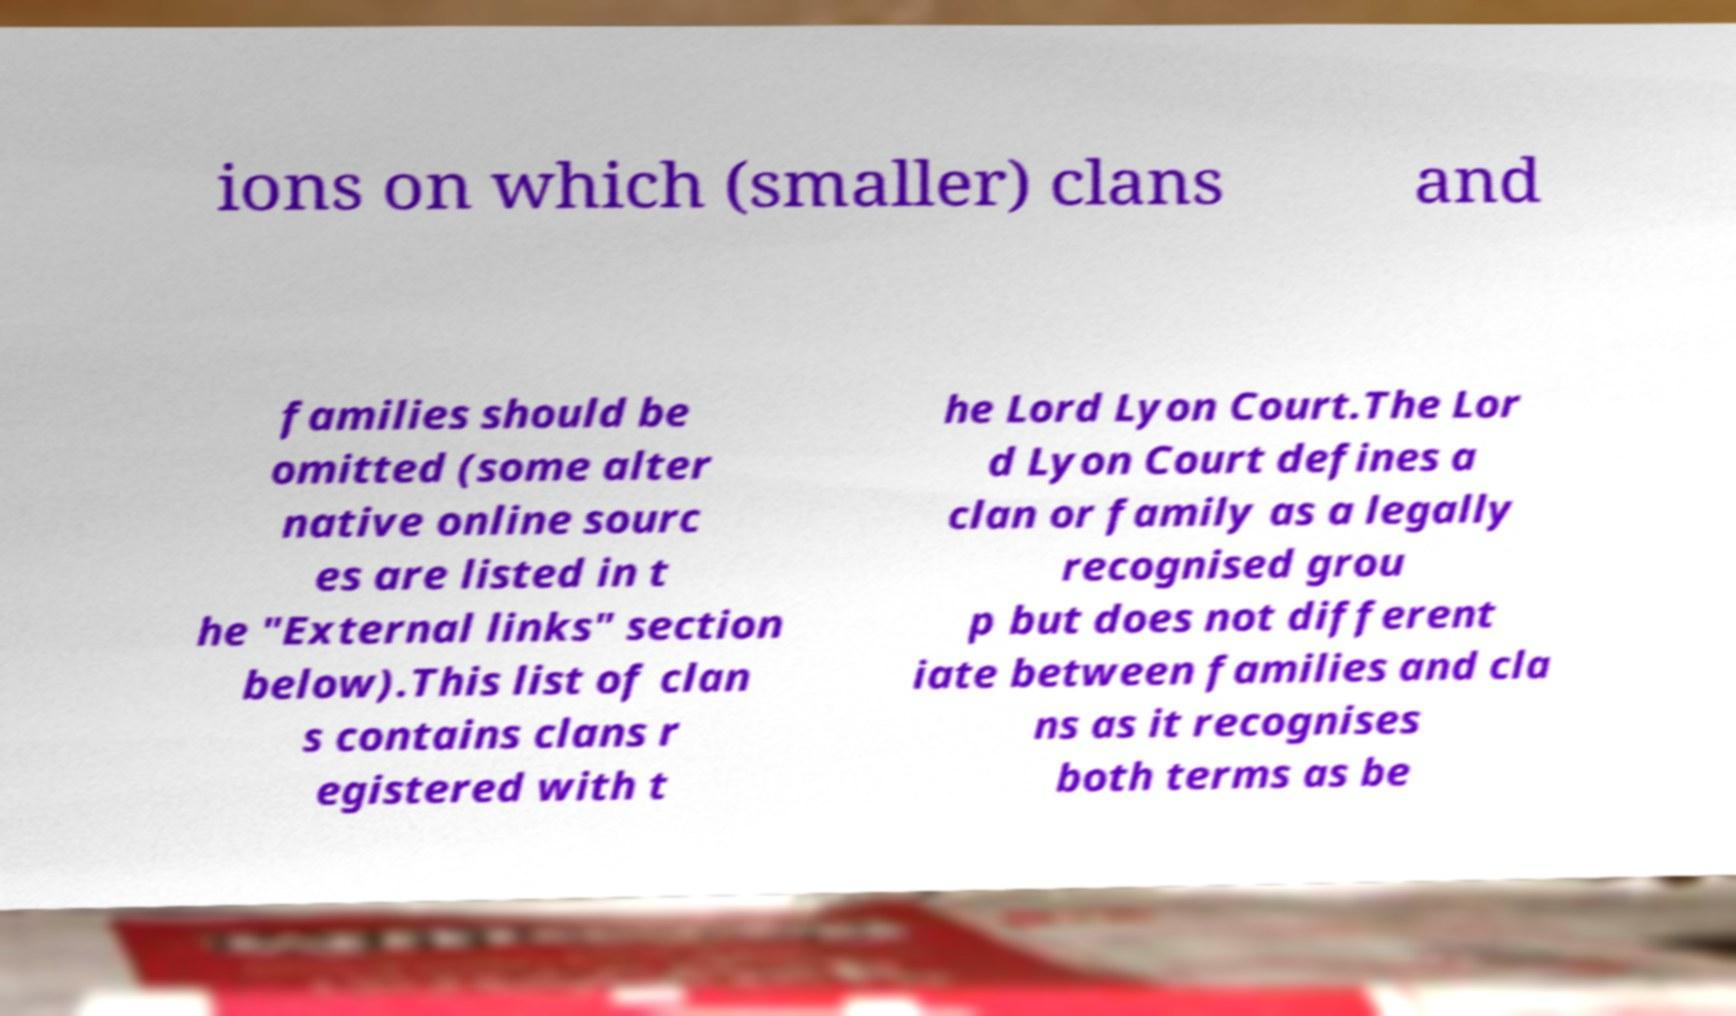I need the written content from this picture converted into text. Can you do that? ions on which (smaller) clans and families should be omitted (some alter native online sourc es are listed in t he "External links" section below).This list of clan s contains clans r egistered with t he Lord Lyon Court.The Lor d Lyon Court defines a clan or family as a legally recognised grou p but does not different iate between families and cla ns as it recognises both terms as be 